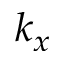<formula> <loc_0><loc_0><loc_500><loc_500>k _ { x }</formula> 